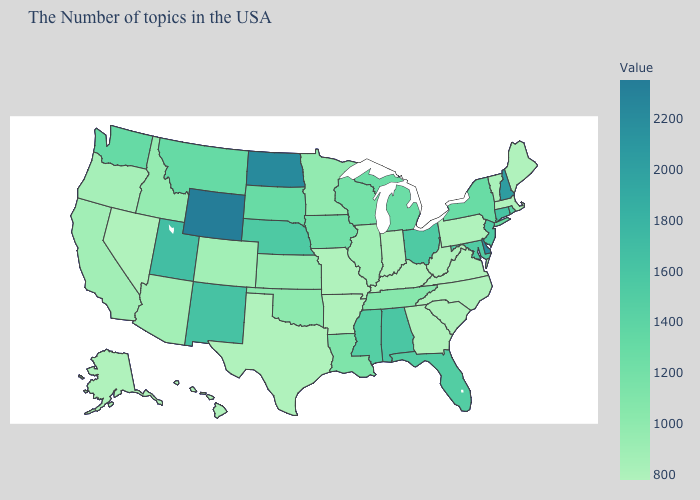Which states have the lowest value in the West?
Give a very brief answer. Nevada, Alaska, Hawaii. Does Connecticut have a lower value than Montana?
Answer briefly. No. Among the states that border Arizona , does Nevada have the lowest value?
Keep it brief. Yes. 